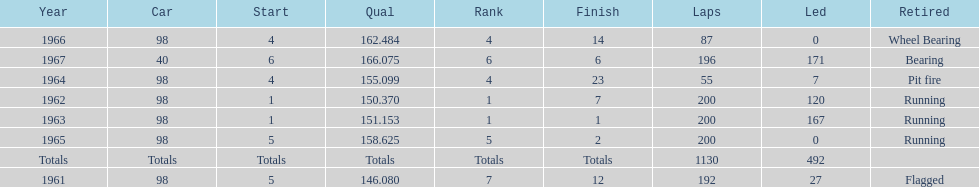How many total laps have been driven in the indy 500? 1130. 